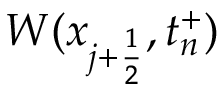Convert formula to latex. <formula><loc_0><loc_0><loc_500><loc_500>W ( x _ { j + \frac { 1 } { 2 } } , t _ { n } ^ { + } )</formula> 